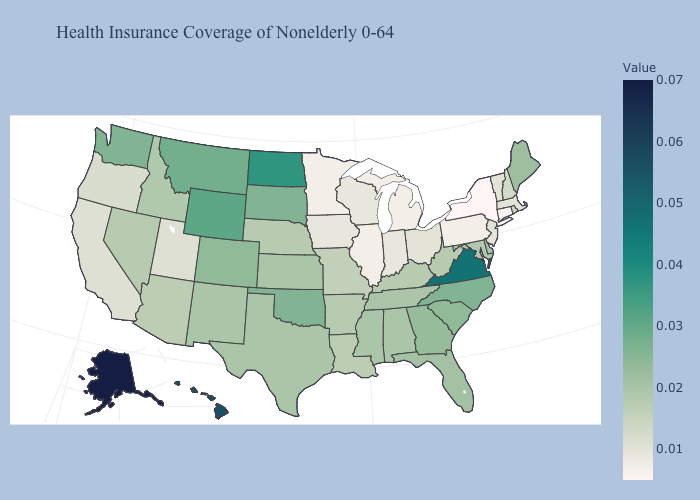Does Alaska have the highest value in the USA?
Short answer required. Yes. Among the states that border Missouri , does Tennessee have the lowest value?
Be succinct. No. Does Nebraska have the highest value in the MidWest?
Answer briefly. No. Does Maine have the highest value in the Northeast?
Short answer required. Yes. 